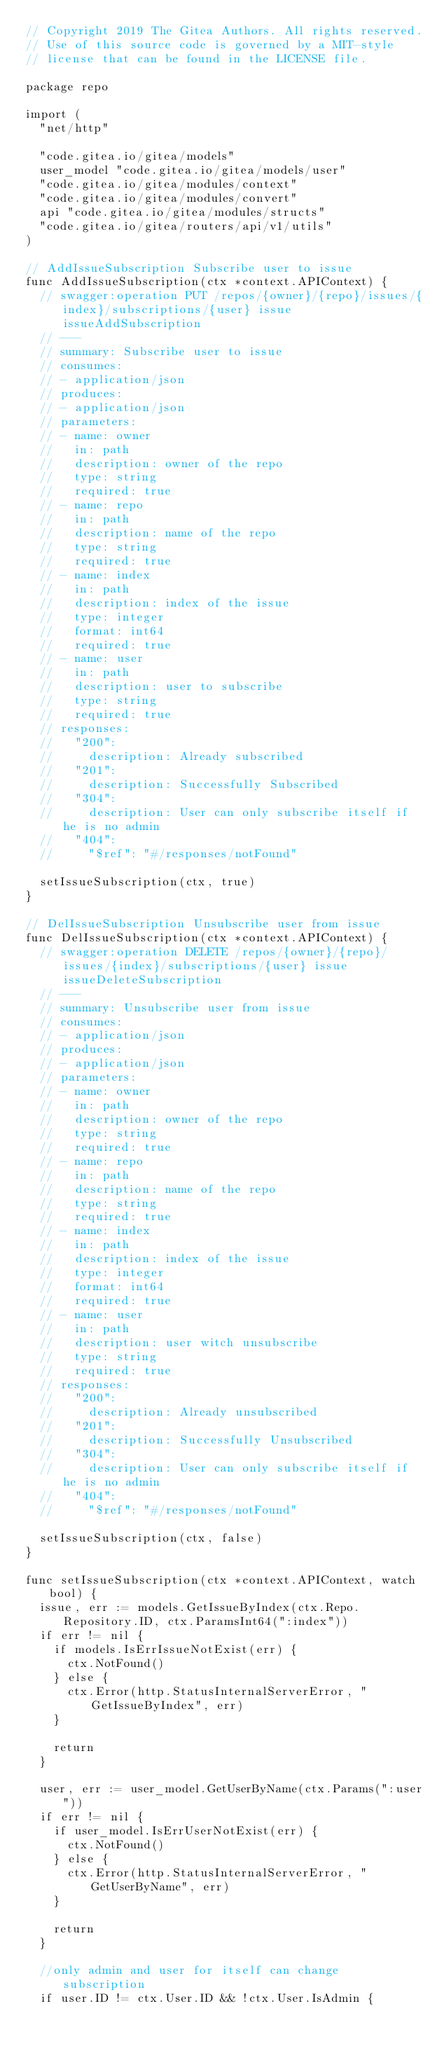<code> <loc_0><loc_0><loc_500><loc_500><_Go_>// Copyright 2019 The Gitea Authors. All rights reserved.
// Use of this source code is governed by a MIT-style
// license that can be found in the LICENSE file.

package repo

import (
	"net/http"

	"code.gitea.io/gitea/models"
	user_model "code.gitea.io/gitea/models/user"
	"code.gitea.io/gitea/modules/context"
	"code.gitea.io/gitea/modules/convert"
	api "code.gitea.io/gitea/modules/structs"
	"code.gitea.io/gitea/routers/api/v1/utils"
)

// AddIssueSubscription Subscribe user to issue
func AddIssueSubscription(ctx *context.APIContext) {
	// swagger:operation PUT /repos/{owner}/{repo}/issues/{index}/subscriptions/{user} issue issueAddSubscription
	// ---
	// summary: Subscribe user to issue
	// consumes:
	// - application/json
	// produces:
	// - application/json
	// parameters:
	// - name: owner
	//   in: path
	//   description: owner of the repo
	//   type: string
	//   required: true
	// - name: repo
	//   in: path
	//   description: name of the repo
	//   type: string
	//   required: true
	// - name: index
	//   in: path
	//   description: index of the issue
	//   type: integer
	//   format: int64
	//   required: true
	// - name: user
	//   in: path
	//   description: user to subscribe
	//   type: string
	//   required: true
	// responses:
	//   "200":
	//     description: Already subscribed
	//   "201":
	//     description: Successfully Subscribed
	//   "304":
	//     description: User can only subscribe itself if he is no admin
	//   "404":
	//     "$ref": "#/responses/notFound"

	setIssueSubscription(ctx, true)
}

// DelIssueSubscription Unsubscribe user from issue
func DelIssueSubscription(ctx *context.APIContext) {
	// swagger:operation DELETE /repos/{owner}/{repo}/issues/{index}/subscriptions/{user} issue issueDeleteSubscription
	// ---
	// summary: Unsubscribe user from issue
	// consumes:
	// - application/json
	// produces:
	// - application/json
	// parameters:
	// - name: owner
	//   in: path
	//   description: owner of the repo
	//   type: string
	//   required: true
	// - name: repo
	//   in: path
	//   description: name of the repo
	//   type: string
	//   required: true
	// - name: index
	//   in: path
	//   description: index of the issue
	//   type: integer
	//   format: int64
	//   required: true
	// - name: user
	//   in: path
	//   description: user witch unsubscribe
	//   type: string
	//   required: true
	// responses:
	//   "200":
	//     description: Already unsubscribed
	//   "201":
	//     description: Successfully Unsubscribed
	//   "304":
	//     description: User can only subscribe itself if he is no admin
	//   "404":
	//     "$ref": "#/responses/notFound"

	setIssueSubscription(ctx, false)
}

func setIssueSubscription(ctx *context.APIContext, watch bool) {
	issue, err := models.GetIssueByIndex(ctx.Repo.Repository.ID, ctx.ParamsInt64(":index"))
	if err != nil {
		if models.IsErrIssueNotExist(err) {
			ctx.NotFound()
		} else {
			ctx.Error(http.StatusInternalServerError, "GetIssueByIndex", err)
		}

		return
	}

	user, err := user_model.GetUserByName(ctx.Params(":user"))
	if err != nil {
		if user_model.IsErrUserNotExist(err) {
			ctx.NotFound()
		} else {
			ctx.Error(http.StatusInternalServerError, "GetUserByName", err)
		}

		return
	}

	//only admin and user for itself can change subscription
	if user.ID != ctx.User.ID && !ctx.User.IsAdmin {</code> 